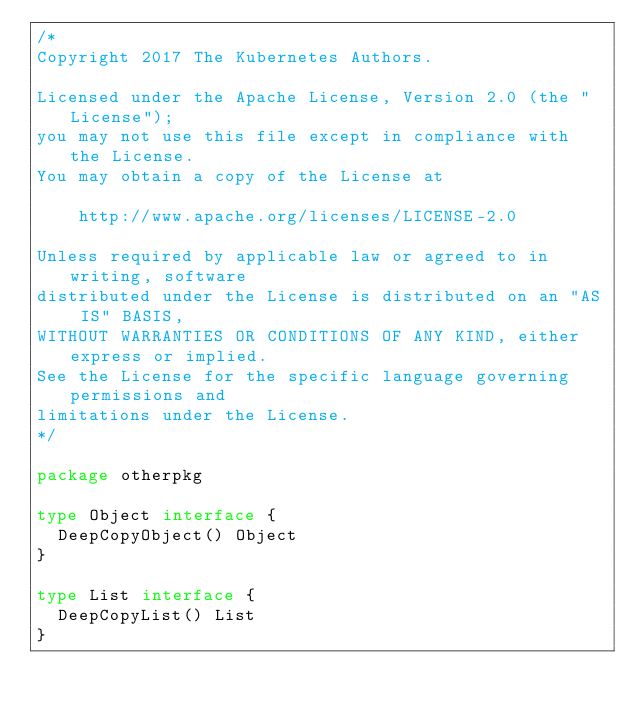Convert code to text. <code><loc_0><loc_0><loc_500><loc_500><_Go_>/*
Copyright 2017 The Kubernetes Authors.

Licensed under the Apache License, Version 2.0 (the "License");
you may not use this file except in compliance with the License.
You may obtain a copy of the License at

    http://www.apache.org/licenses/LICENSE-2.0

Unless required by applicable law or agreed to in writing, software
distributed under the License is distributed on an "AS IS" BASIS,
WITHOUT WARRANTIES OR CONDITIONS OF ANY KIND, either express or implied.
See the License for the specific language governing permissions and
limitations under the License.
*/

package otherpkg

type Object interface {
	DeepCopyObject() Object
}

type List interface {
	DeepCopyList() List
}
</code> 